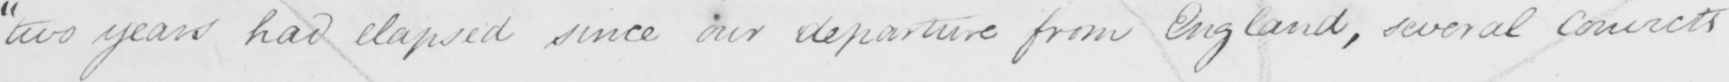Can you read and transcribe this handwriting? " two years had elapsed since our departure from England , several convicts 